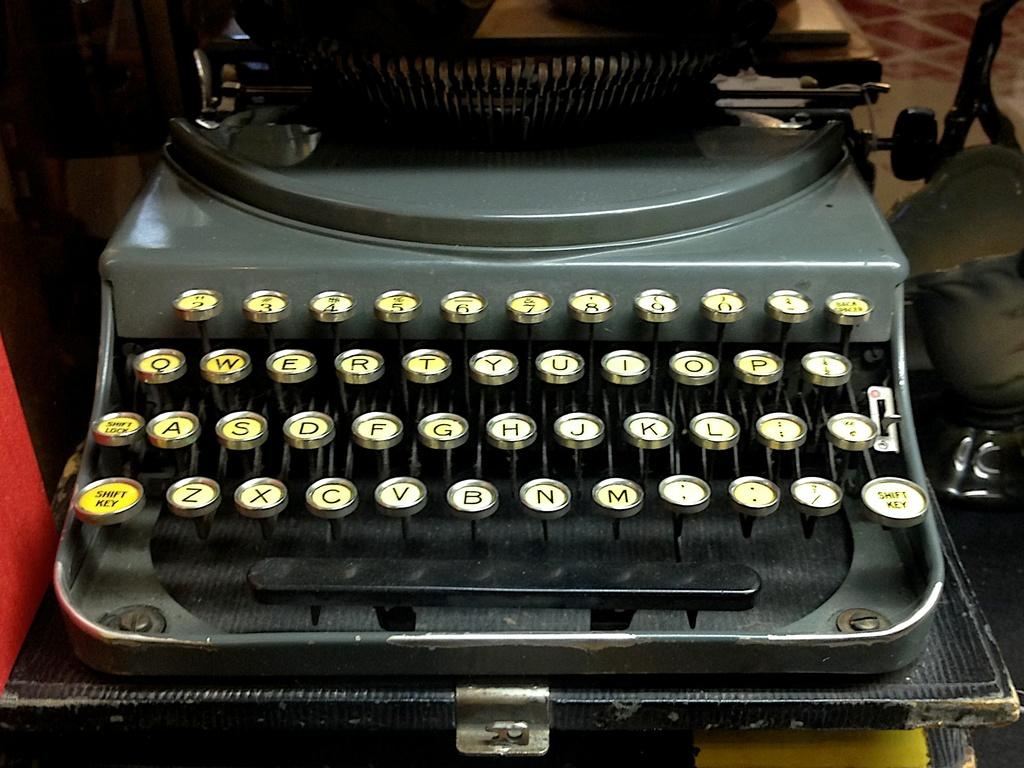<image>
Create a compact narrative representing the image presented. An old fashioned type writer with keys on either side that say Shift Key. 